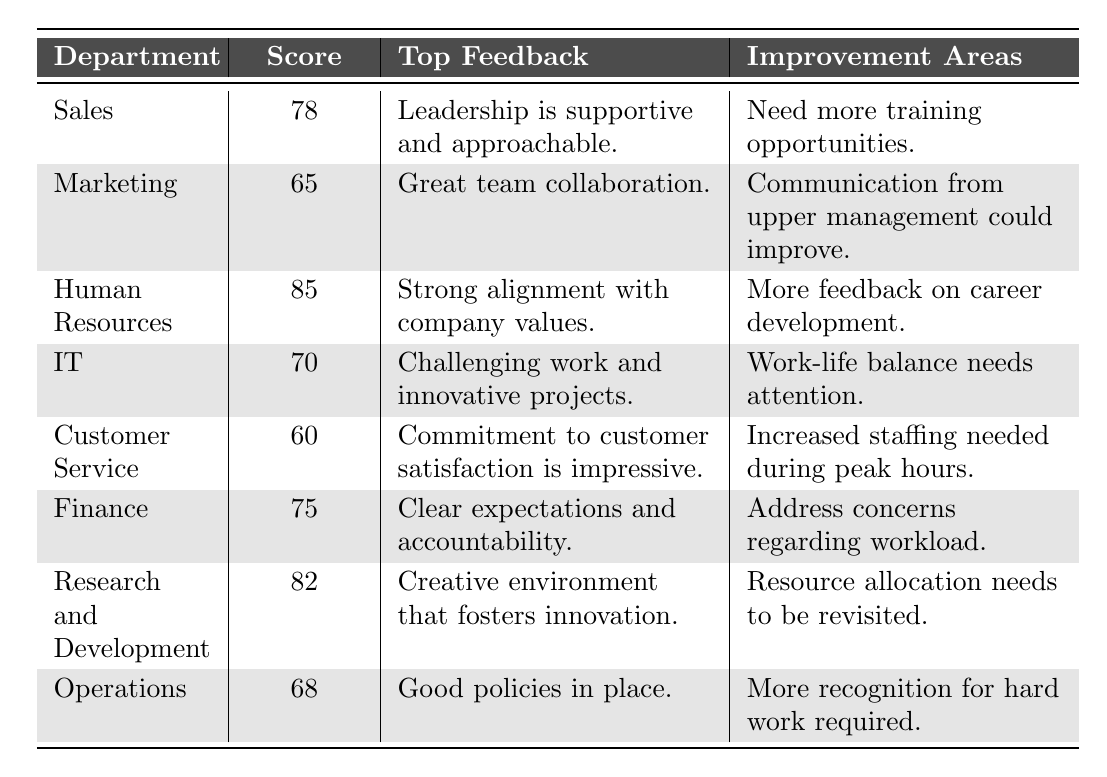What is the engagement score for the Human Resources department? The table provides a direct value for the Human Resources department in the "Score" column, which is 85.
Answer: 85 Which department has the lowest engagement score? By comparing the engagement scores listed in the table, Customer Service has the lowest score of 60.
Answer: Customer Service What are the top feedback points for the IT department? According to the table, the top feedback for the IT department is "Challenging work and innovative projects."
Answer: Challenging work and innovative projects What is the average engagement score across all departments? To calculate the average, sum the scores (78 + 65 + 85 + 70 + 60 + 75 + 82 + 68 = 685) and divide by the number of departments (8). Thus, the average is 685/8 = 85.625.
Answer: 85.625 Is there a department where work-life balance needs attention? Yes, the IT department states that "Work-life balance needs attention," indicating this as an area for improvement.
Answer: Yes Which departments have scores above 75? The departments with scores above 75 are Human Resources (85), Research and Development (82), and Sales (78).
Answer: Human Resources, Research and Development, Sales Calculate the difference between the highest and lowest engagement scores. The highest engagement score is 85 (Human Resources), and the lowest is 60 (Customer Service), so the difference is 85 - 60 = 25.
Answer: 25 Which department mentioned the need for increased staffing during peak hours? The Customer Service department mentioned "Increased staffing needed during peak hours" in their improvement areas.
Answer: Customer Service What feedback does the Marketing department highlight regarding upper management? The feedback from the Marketing department regarding upper management indicates that "Communication from upper management could improve."
Answer: Communication could improve Are there any departments that have feedback about recognition for hard work? Yes, the Operations department mentioned the need for "More recognition for hard work required."
Answer: Yes 